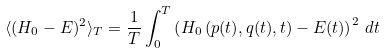<formula> <loc_0><loc_0><loc_500><loc_500>\langle ( H _ { 0 } - E ) ^ { 2 } \rangle _ { T } = \frac { 1 } { T } \int _ { 0 } ^ { T } \left ( H _ { 0 } \left ( p ( t ) , q ( t ) , t \right ) - E ( t ) \right ) ^ { 2 } \, d t</formula> 